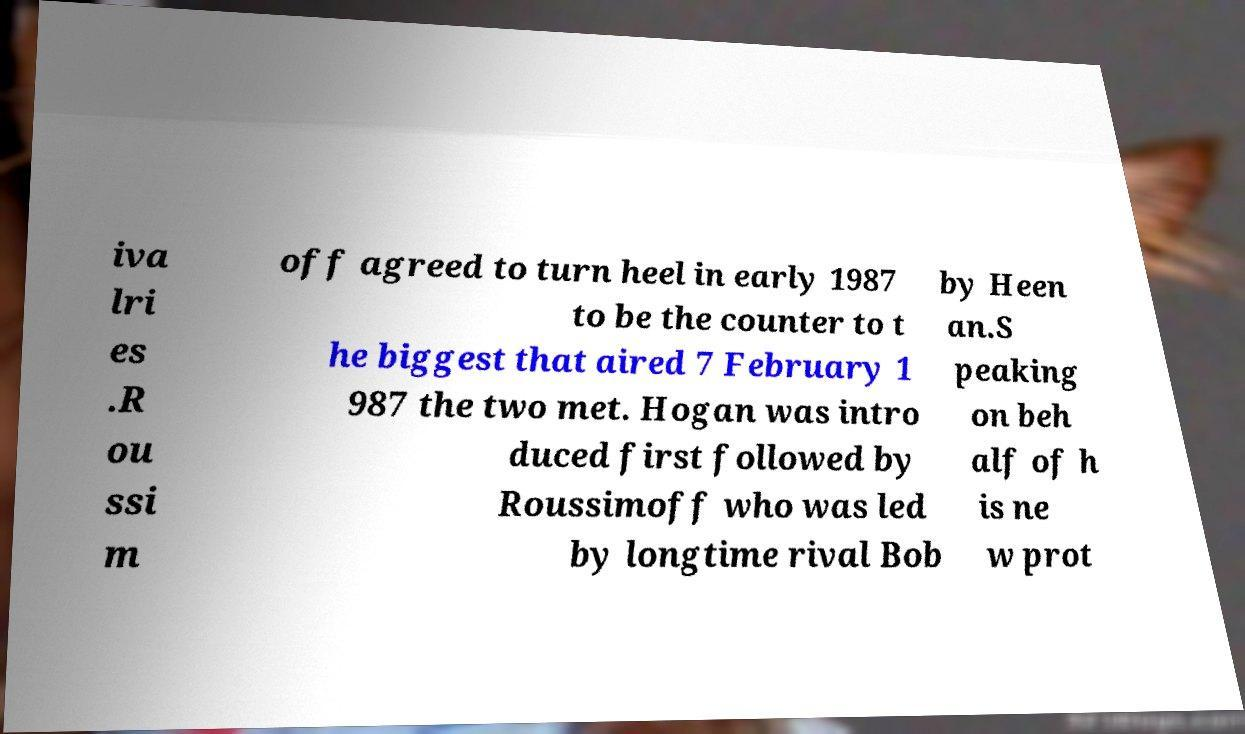Could you extract and type out the text from this image? iva lri es .R ou ssi m off agreed to turn heel in early 1987 to be the counter to t he biggest that aired 7 February 1 987 the two met. Hogan was intro duced first followed by Roussimoff who was led by longtime rival Bob by Heen an.S peaking on beh alf of h is ne w prot 